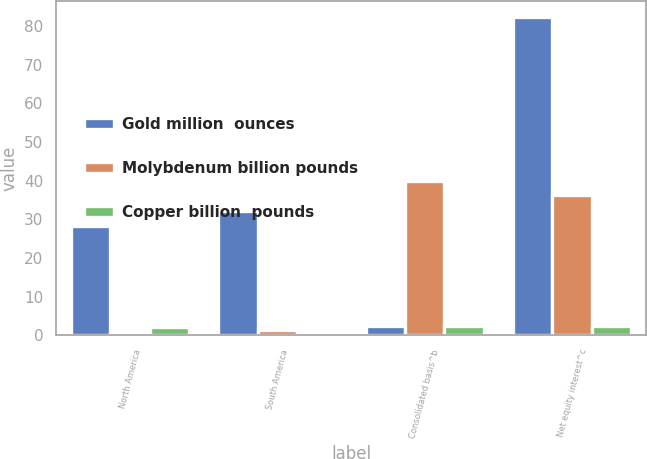Convert chart. <chart><loc_0><loc_0><loc_500><loc_500><stacked_bar_chart><ecel><fcel>North America<fcel>South America<fcel>Consolidated basis^b<fcel>Net equity interest^c<nl><fcel>Gold million  ounces<fcel>28.3<fcel>32.2<fcel>2.48<fcel>82.4<nl><fcel>Molybdenum billion pounds<fcel>0.2<fcel>1.3<fcel>40<fcel>36.2<nl><fcel>Copper billion  pounds<fcel>2.08<fcel>0.4<fcel>2.48<fcel>2.3<nl></chart> 